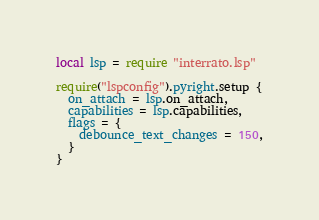<code> <loc_0><loc_0><loc_500><loc_500><_Lua_>local lsp = require "interrato.lsp"

require("lspconfig").pyright.setup {
  on_attach = lsp.on_attach,
  capabilities = lsp.capabilities,
  flags = {
    debounce_text_changes = 150,
  }
}
</code> 